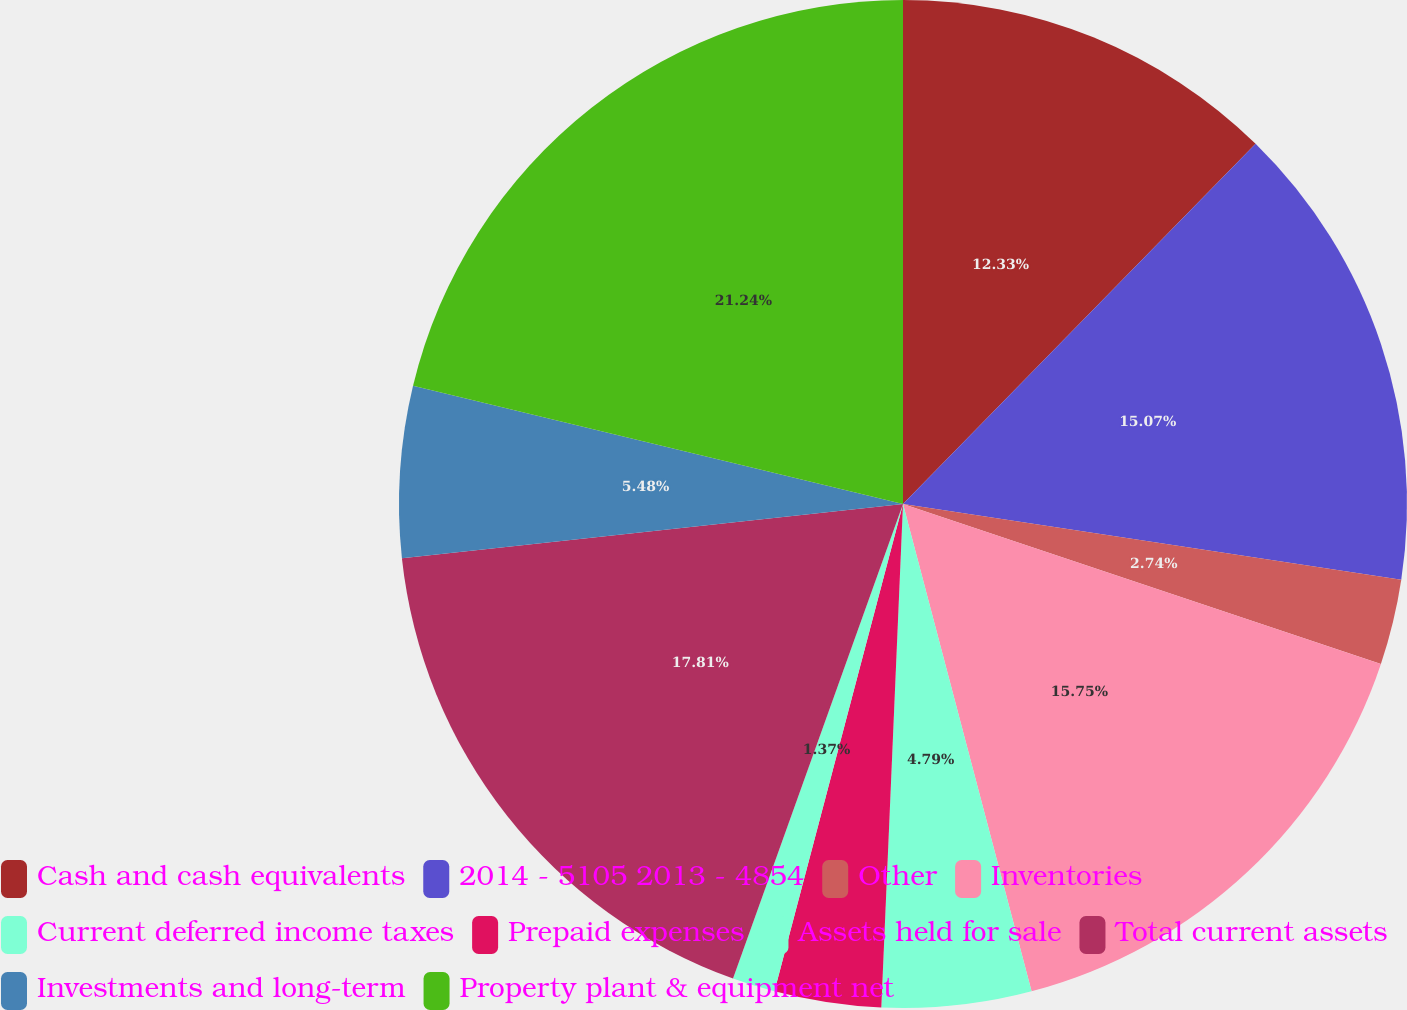Convert chart. <chart><loc_0><loc_0><loc_500><loc_500><pie_chart><fcel>Cash and cash equivalents<fcel>2014 - 5105 2013 - 4854<fcel>Other<fcel>Inventories<fcel>Current deferred income taxes<fcel>Prepaid expenses<fcel>Assets held for sale<fcel>Total current assets<fcel>Investments and long-term<fcel>Property plant & equipment net<nl><fcel>12.33%<fcel>15.07%<fcel>2.74%<fcel>15.75%<fcel>4.79%<fcel>3.42%<fcel>1.37%<fcel>17.81%<fcel>5.48%<fcel>21.23%<nl></chart> 